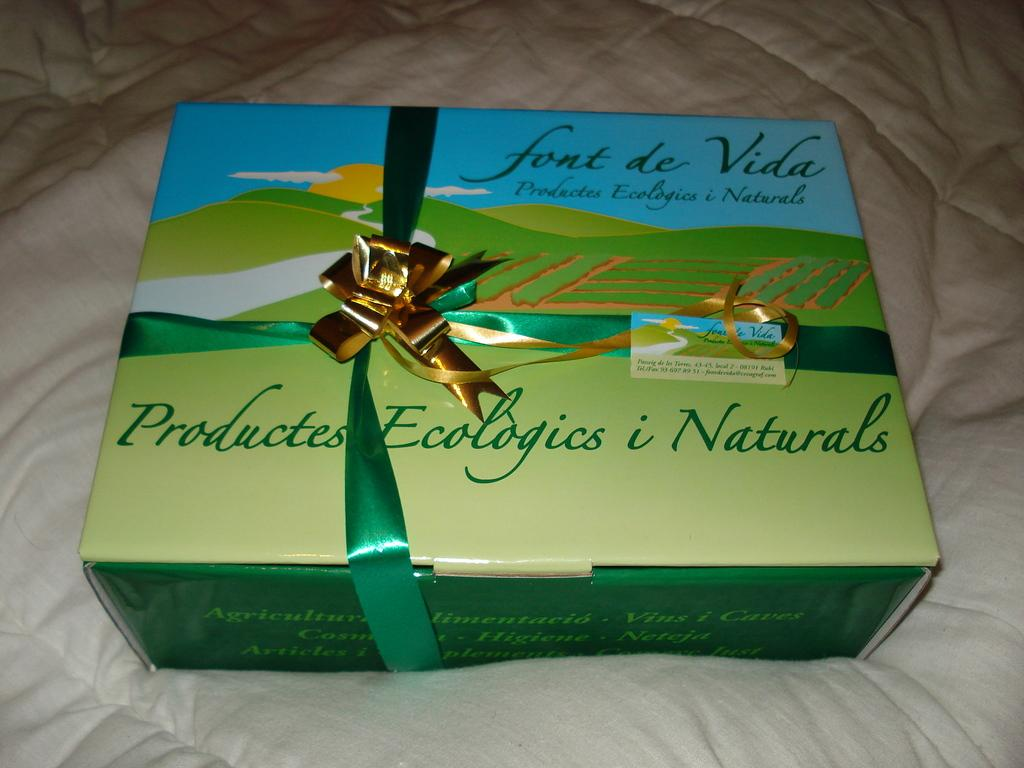<image>
Give a short and clear explanation of the subsequent image. A box of font de Vida Productes Ecologics i Naturals has a ribbon and a bow on it. 